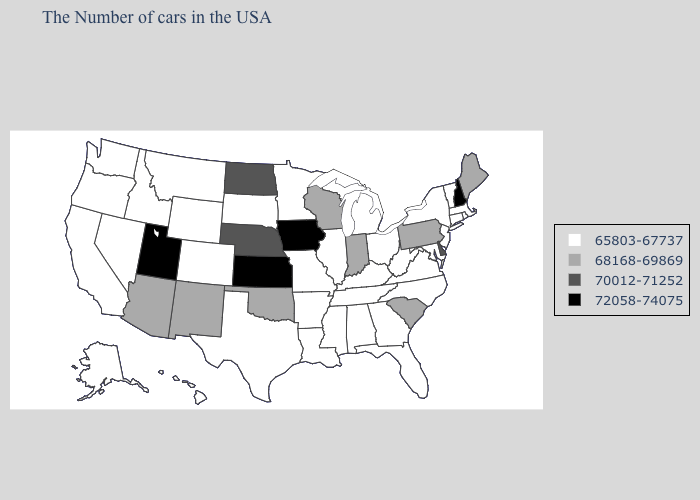How many symbols are there in the legend?
Be succinct. 4. Does Florida have the highest value in the USA?
Give a very brief answer. No. Name the states that have a value in the range 68168-69869?
Give a very brief answer. Maine, Pennsylvania, South Carolina, Indiana, Wisconsin, Oklahoma, New Mexico, Arizona. Name the states that have a value in the range 72058-74075?
Concise answer only. New Hampshire, Iowa, Kansas, Utah. Does Wyoming have a higher value than Iowa?
Quick response, please. No. Among the states that border Louisiana , which have the highest value?
Short answer required. Mississippi, Arkansas, Texas. Name the states that have a value in the range 72058-74075?
Write a very short answer. New Hampshire, Iowa, Kansas, Utah. Which states have the lowest value in the USA?
Write a very short answer. Massachusetts, Rhode Island, Vermont, Connecticut, New York, New Jersey, Maryland, Virginia, North Carolina, West Virginia, Ohio, Florida, Georgia, Michigan, Kentucky, Alabama, Tennessee, Illinois, Mississippi, Louisiana, Missouri, Arkansas, Minnesota, Texas, South Dakota, Wyoming, Colorado, Montana, Idaho, Nevada, California, Washington, Oregon, Alaska, Hawaii. Name the states that have a value in the range 68168-69869?
Answer briefly. Maine, Pennsylvania, South Carolina, Indiana, Wisconsin, Oklahoma, New Mexico, Arizona. What is the value of New Jersey?
Quick response, please. 65803-67737. What is the highest value in the USA?
Short answer required. 72058-74075. Does Indiana have the lowest value in the USA?
Short answer required. No. Name the states that have a value in the range 65803-67737?
Short answer required. Massachusetts, Rhode Island, Vermont, Connecticut, New York, New Jersey, Maryland, Virginia, North Carolina, West Virginia, Ohio, Florida, Georgia, Michigan, Kentucky, Alabama, Tennessee, Illinois, Mississippi, Louisiana, Missouri, Arkansas, Minnesota, Texas, South Dakota, Wyoming, Colorado, Montana, Idaho, Nevada, California, Washington, Oregon, Alaska, Hawaii. What is the value of Maryland?
Give a very brief answer. 65803-67737. What is the value of Texas?
Quick response, please. 65803-67737. 